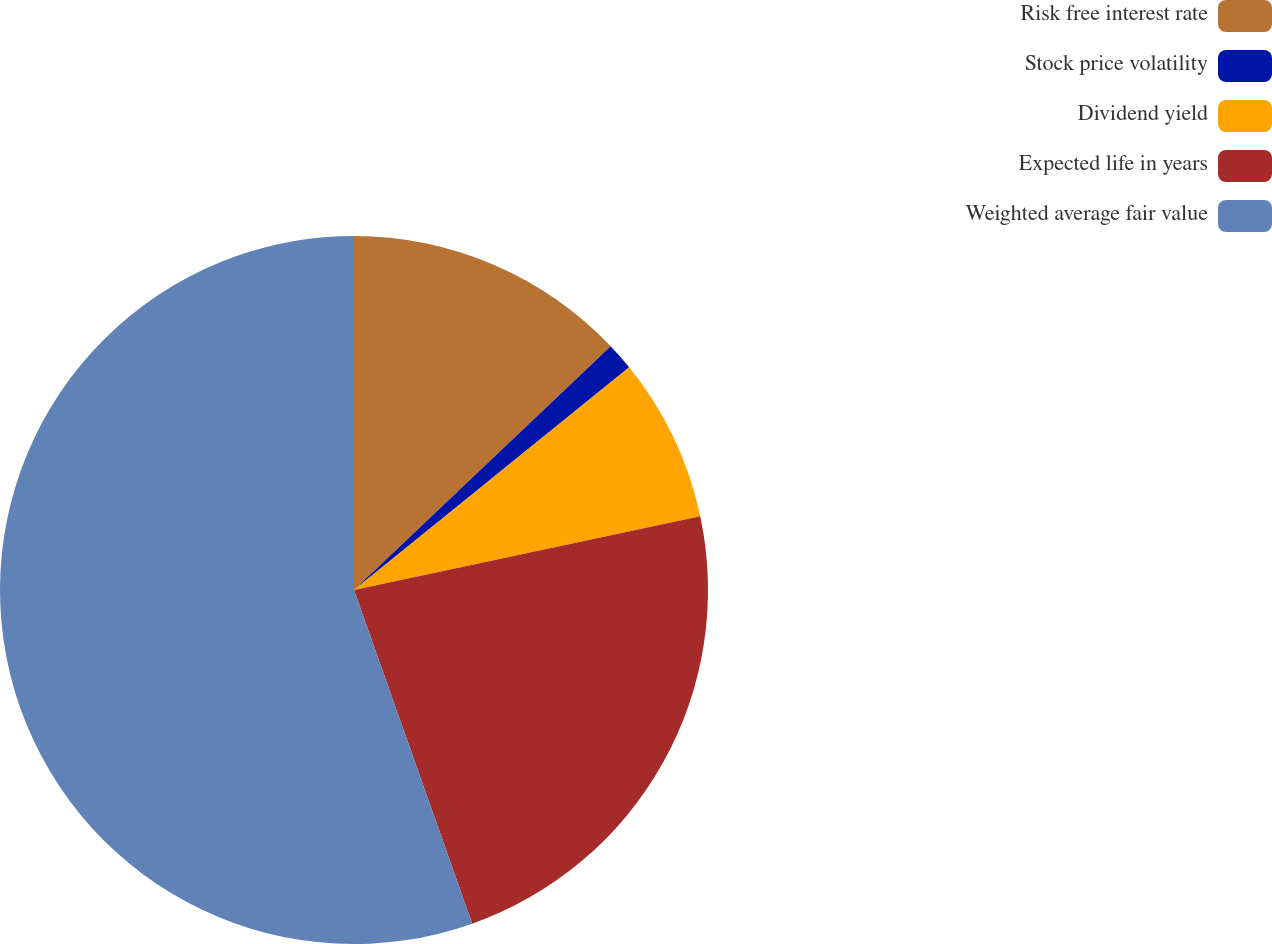Convert chart to OTSL. <chart><loc_0><loc_0><loc_500><loc_500><pie_chart><fcel>Risk free interest rate<fcel>Stock price volatility<fcel>Dividend yield<fcel>Expected life in years<fcel>Weighted average fair value<nl><fcel>12.91%<fcel>1.26%<fcel>7.49%<fcel>22.92%<fcel>55.42%<nl></chart> 